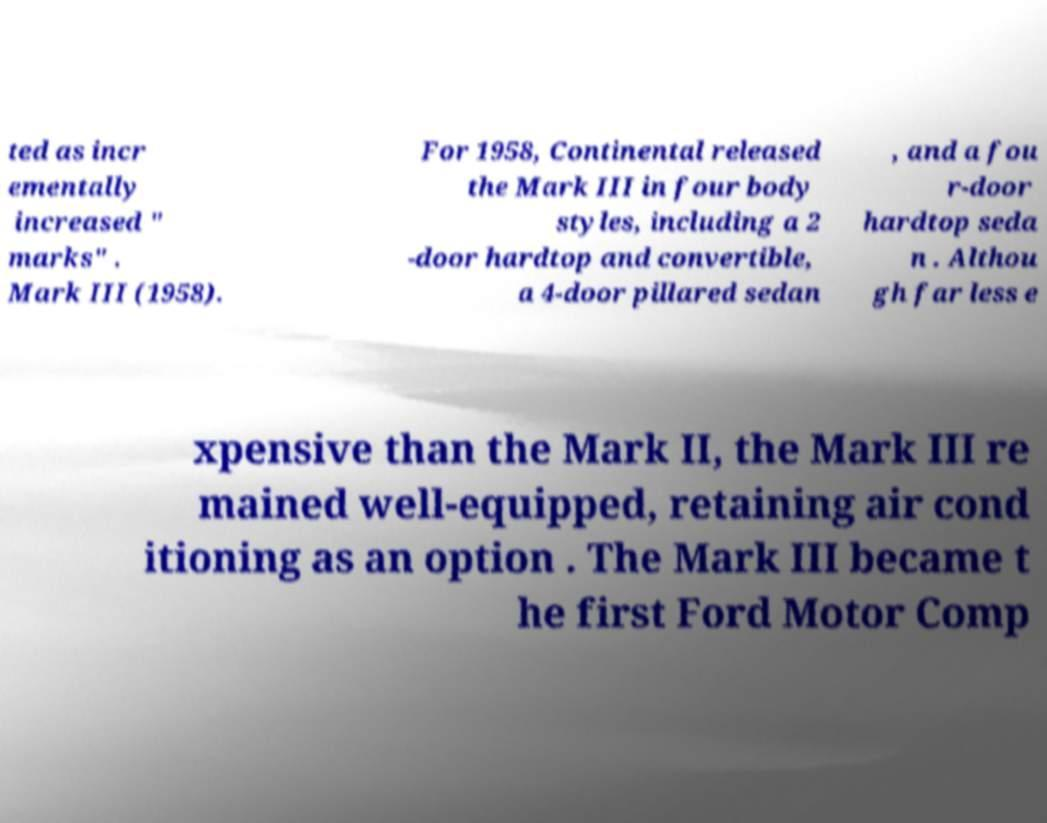Please identify and transcribe the text found in this image. ted as incr ementally increased " marks" . Mark III (1958). For 1958, Continental released the Mark III in four body styles, including a 2 -door hardtop and convertible, a 4-door pillared sedan , and a fou r-door hardtop seda n . Althou gh far less e xpensive than the Mark II, the Mark III re mained well-equipped, retaining air cond itioning as an option . The Mark III became t he first Ford Motor Comp 